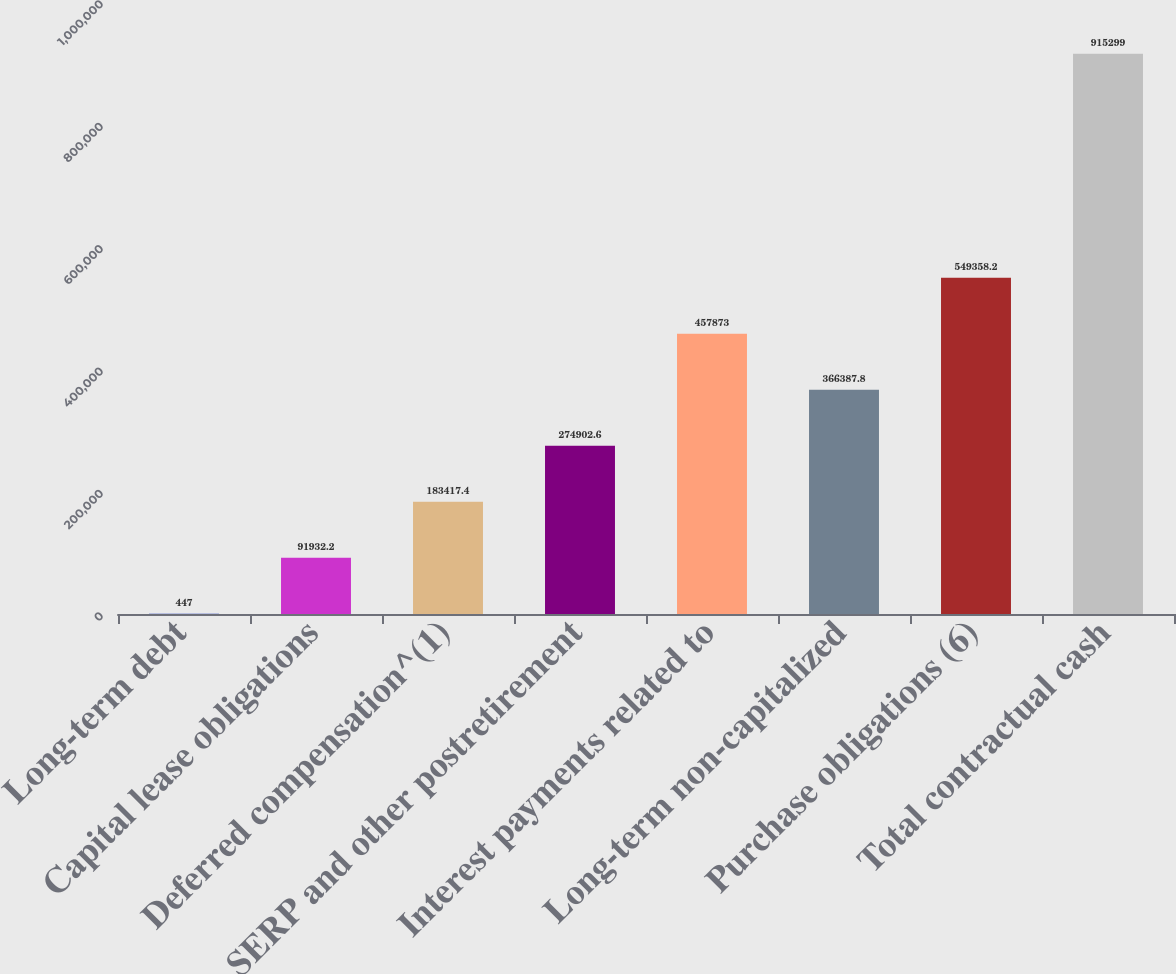Convert chart to OTSL. <chart><loc_0><loc_0><loc_500><loc_500><bar_chart><fcel>Long-term debt<fcel>Capital lease obligations<fcel>Deferred compensation^(1)<fcel>SERP and other postretirement<fcel>Interest payments related to<fcel>Long-term non-capitalized<fcel>Purchase obligations (6)<fcel>Total contractual cash<nl><fcel>447<fcel>91932.2<fcel>183417<fcel>274903<fcel>457873<fcel>366388<fcel>549358<fcel>915299<nl></chart> 